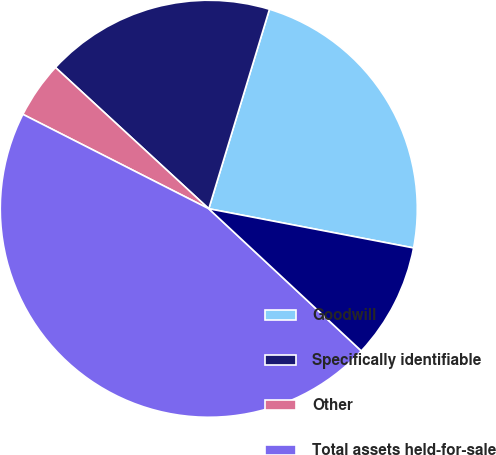<chart> <loc_0><loc_0><loc_500><loc_500><pie_chart><fcel>Goodwill<fcel>Specifically identifiable<fcel>Other<fcel>Total assets held-for-sale<fcel>ies held-for-sale Liabilit<nl><fcel>23.31%<fcel>17.85%<fcel>4.37%<fcel>45.54%<fcel>8.93%<nl></chart> 